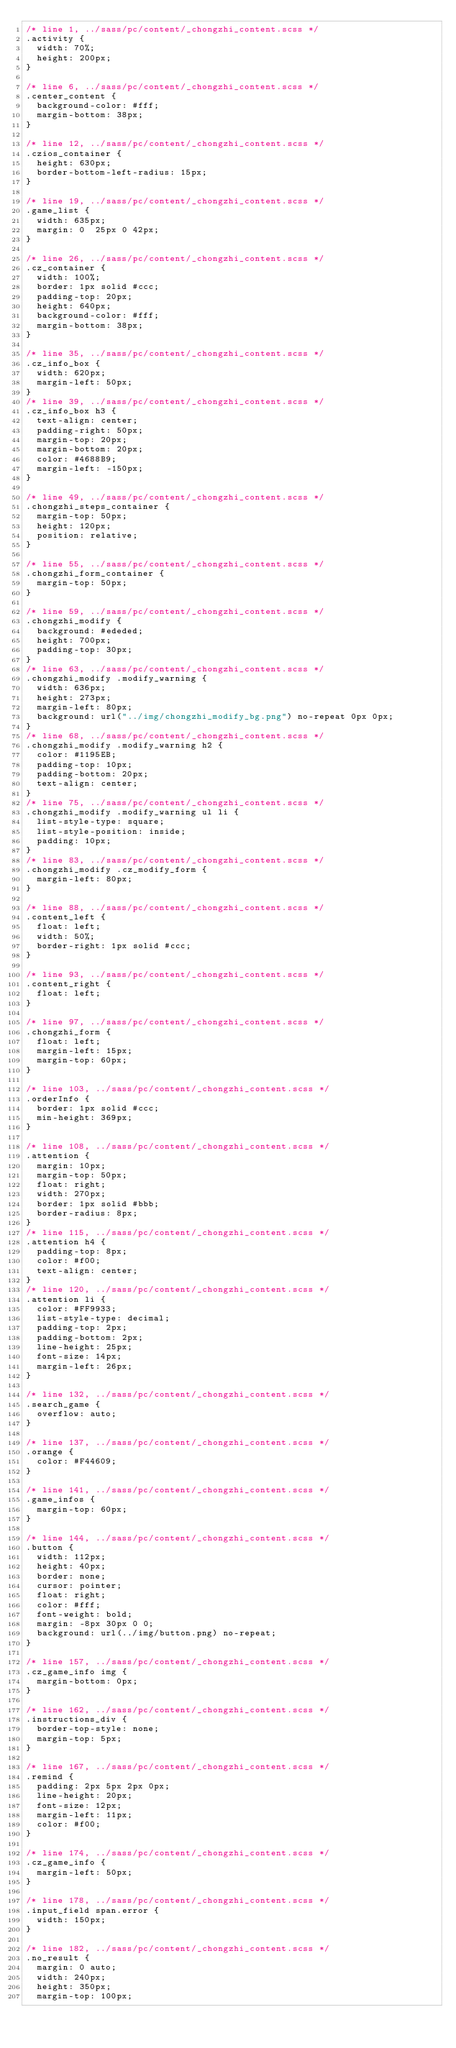Convert code to text. <code><loc_0><loc_0><loc_500><loc_500><_CSS_>/* line 1, ../sass/pc/content/_chongzhi_content.scss */
.activity {
  width: 70%;
  height: 200px;
}

/* line 6, ../sass/pc/content/_chongzhi_content.scss */
.center_content {
  background-color: #fff;
  margin-bottom: 38px;
}

/* line 12, ../sass/pc/content/_chongzhi_content.scss */
.czios_container {
  height: 630px;
  border-bottom-left-radius: 15px;
}

/* line 19, ../sass/pc/content/_chongzhi_content.scss */
.game_list {
  width: 635px;
  margin: 0  25px 0 42px;
}

/* line 26, ../sass/pc/content/_chongzhi_content.scss */
.cz_container {
  width: 100%;
  border: 1px solid #ccc;
  padding-top: 20px;
  height: 640px;
  background-color: #fff;
  margin-bottom: 38px;
}

/* line 35, ../sass/pc/content/_chongzhi_content.scss */
.cz_info_box {
  width: 620px;
  margin-left: 50px;
}
/* line 39, ../sass/pc/content/_chongzhi_content.scss */
.cz_info_box h3 {
  text-align: center;
  padding-right: 50px;
  margin-top: 20px;
  margin-bottom: 20px;
  color: #4688B9;
  margin-left: -150px;
}

/* line 49, ../sass/pc/content/_chongzhi_content.scss */
.chongzhi_steps_container {
  margin-top: 50px;
  height: 120px;
  position: relative;
}

/* line 55, ../sass/pc/content/_chongzhi_content.scss */
.chongzhi_form_container {
  margin-top: 50px;
}

/* line 59, ../sass/pc/content/_chongzhi_content.scss */
.chongzhi_modify {
  background: #ededed;
  height: 700px;
  padding-top: 30px;
}
/* line 63, ../sass/pc/content/_chongzhi_content.scss */
.chongzhi_modify .modify_warning {
  width: 636px;
  height: 273px;
  margin-left: 80px;
  background: url("../img/chongzhi_modify_bg.png") no-repeat 0px 0px;
}
/* line 68, ../sass/pc/content/_chongzhi_content.scss */
.chongzhi_modify .modify_warning h2 {
  color: #1195EB;
  padding-top: 10px;
  padding-bottom: 20px;
  text-align: center;
}
/* line 75, ../sass/pc/content/_chongzhi_content.scss */
.chongzhi_modify .modify_warning ul li {
  list-style-type: square;
  list-style-position: inside;
  padding: 10px;
}
/* line 83, ../sass/pc/content/_chongzhi_content.scss */
.chongzhi_modify .cz_modify_form {
  margin-left: 80px;
}

/* line 88, ../sass/pc/content/_chongzhi_content.scss */
.content_left {
  float: left;
  width: 50%;
  border-right: 1px solid #ccc;
}

/* line 93, ../sass/pc/content/_chongzhi_content.scss */
.content_right {
  float: left;
}

/* line 97, ../sass/pc/content/_chongzhi_content.scss */
.chongzhi_form {
  float: left;
  margin-left: 15px;
  margin-top: 60px;
}

/* line 103, ../sass/pc/content/_chongzhi_content.scss */
.orderInfo {
  border: 1px solid #ccc;
  min-height: 369px;
}

/* line 108, ../sass/pc/content/_chongzhi_content.scss */
.attention {
  margin: 10px;
  margin-top: 50px;
  float: right;
  width: 270px;
  border: 1px solid #bbb;
  border-radius: 8px;
}
/* line 115, ../sass/pc/content/_chongzhi_content.scss */
.attention h4 {
  padding-top: 8px;
  color: #f00;
  text-align: center;
}
/* line 120, ../sass/pc/content/_chongzhi_content.scss */
.attention li {
  color: #FF9933;
  list-style-type: decimal;
  padding-top: 2px;
  padding-bottom: 2px;
  line-height: 25px;
  font-size: 14px;
  margin-left: 26px;
}

/* line 132, ../sass/pc/content/_chongzhi_content.scss */
.search_game {
  overflow: auto;
}

/* line 137, ../sass/pc/content/_chongzhi_content.scss */
.orange {
  color: #F44609;
}

/* line 141, ../sass/pc/content/_chongzhi_content.scss */
.game_infos {
  margin-top: 60px;
}

/* line 144, ../sass/pc/content/_chongzhi_content.scss */
.button {
  width: 112px;
  height: 40px;
  border: none;
  cursor: pointer;
  float: right;
  color: #fff;
  font-weight: bold;
  margin: -8px 30px 0 0;
  background: url(../img/button.png) no-repeat;
}

/* line 157, ../sass/pc/content/_chongzhi_content.scss */
.cz_game_info img {
  margin-bottom: 0px;
}

/* line 162, ../sass/pc/content/_chongzhi_content.scss */
.instructions_div {
  border-top-style: none;
  margin-top: 5px;
}

/* line 167, ../sass/pc/content/_chongzhi_content.scss */
.remind {
  padding: 2px 5px 2px 0px;
  line-height: 20px;
  font-size: 12px;
  margin-left: 11px;
  color: #f00;
}

/* line 174, ../sass/pc/content/_chongzhi_content.scss */
.cz_game_info {
  margin-left: 50px;
}

/* line 178, ../sass/pc/content/_chongzhi_content.scss */
.input_field span.error {
  width: 150px;
}

/* line 182, ../sass/pc/content/_chongzhi_content.scss */
.no_result {
  margin: 0 auto;
  width: 240px;
  height: 350px;
  margin-top: 100px;</code> 